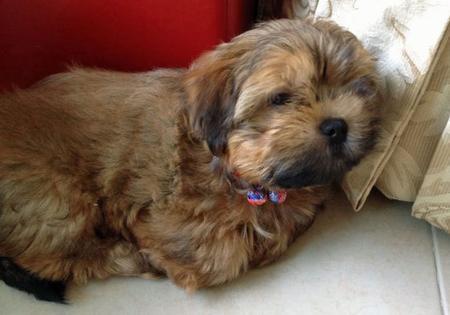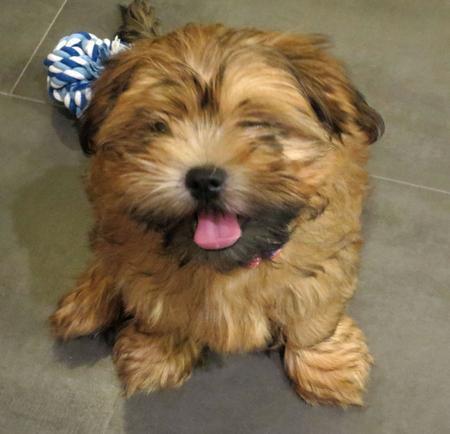The first image is the image on the left, the second image is the image on the right. Given the left and right images, does the statement "Some type of small toy is next to a fluffy dog in one image." hold true? Answer yes or no. Yes. 